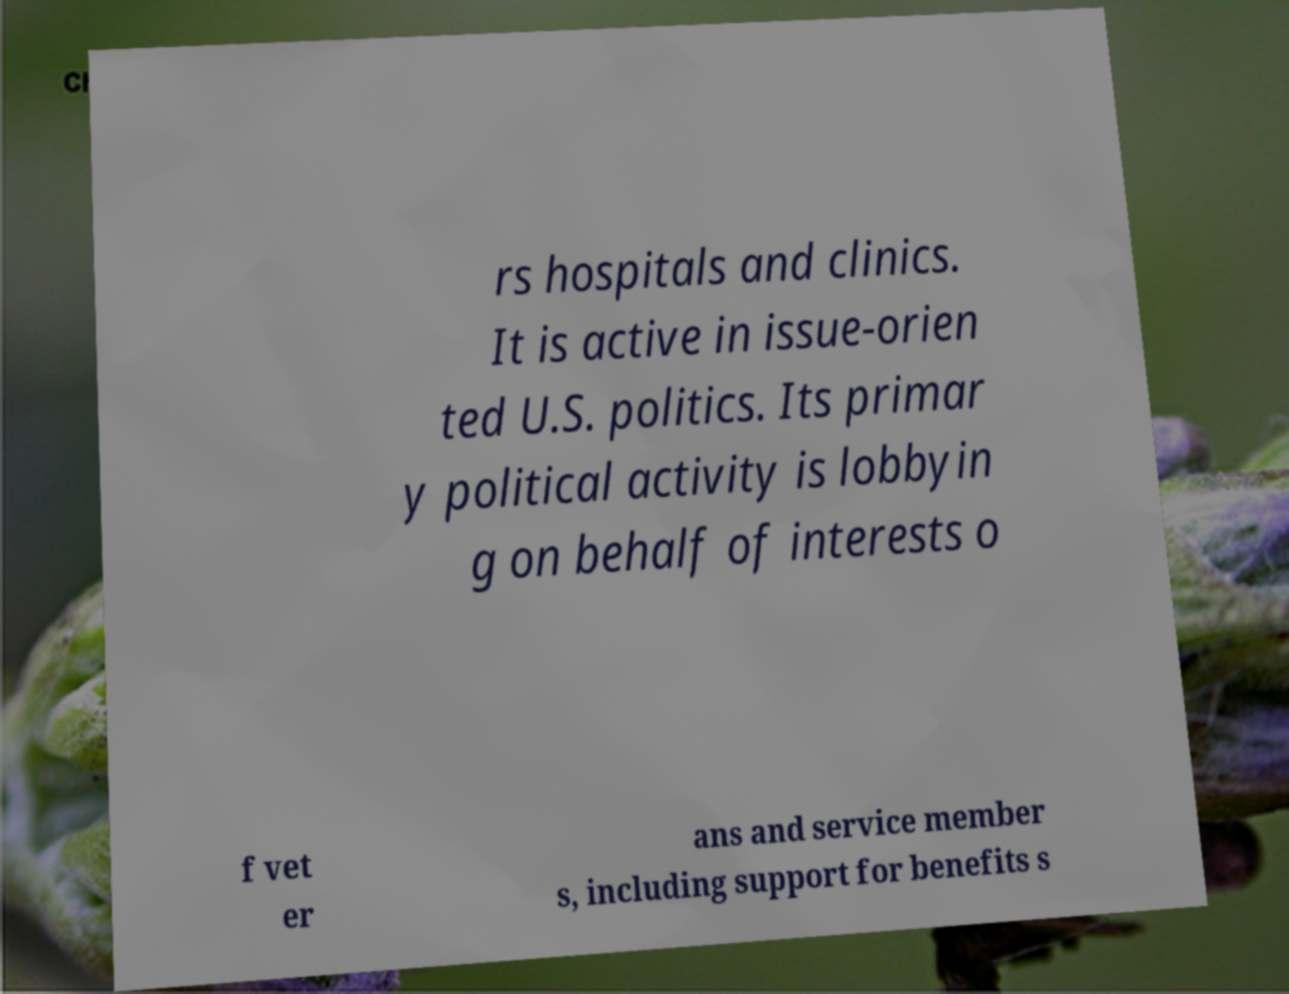Please read and relay the text visible in this image. What does it say? rs hospitals and clinics. It is active in issue-orien ted U.S. politics. Its primar y political activity is lobbyin g on behalf of interests o f vet er ans and service member s, including support for benefits s 